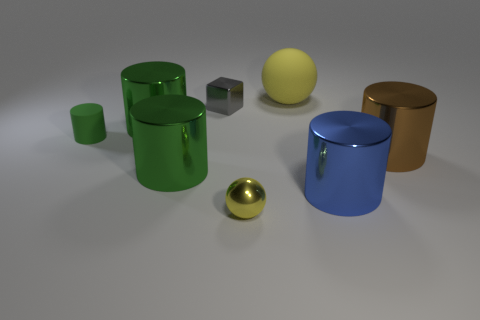There is a small thing that is both to the right of the small green rubber cylinder and behind the large blue shiny cylinder; what material is it made of?
Keep it short and to the point. Metal. Are there any blue metallic cylinders that have the same size as the brown thing?
Offer a very short reply. Yes. What number of yellow metallic objects are there?
Your response must be concise. 1. What number of big metal objects are behind the tiny green cylinder?
Give a very brief answer. 1. Does the big brown cylinder have the same material as the cube?
Give a very brief answer. Yes. What number of yellow balls are behind the tiny gray metal object and in front of the small gray thing?
Your answer should be compact. 0. What number of other things are the same color as the small ball?
Make the answer very short. 1. How many blue objects are large balls or big cylinders?
Provide a succinct answer. 1. What size is the brown cylinder?
Your answer should be compact. Large. How many shiny things are cylinders or yellow objects?
Give a very brief answer. 5. 